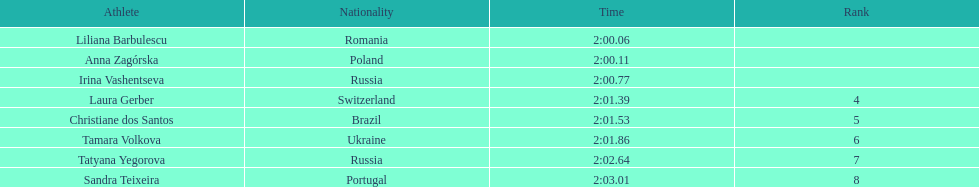How many runners finished with their time below 2:01? 3. 